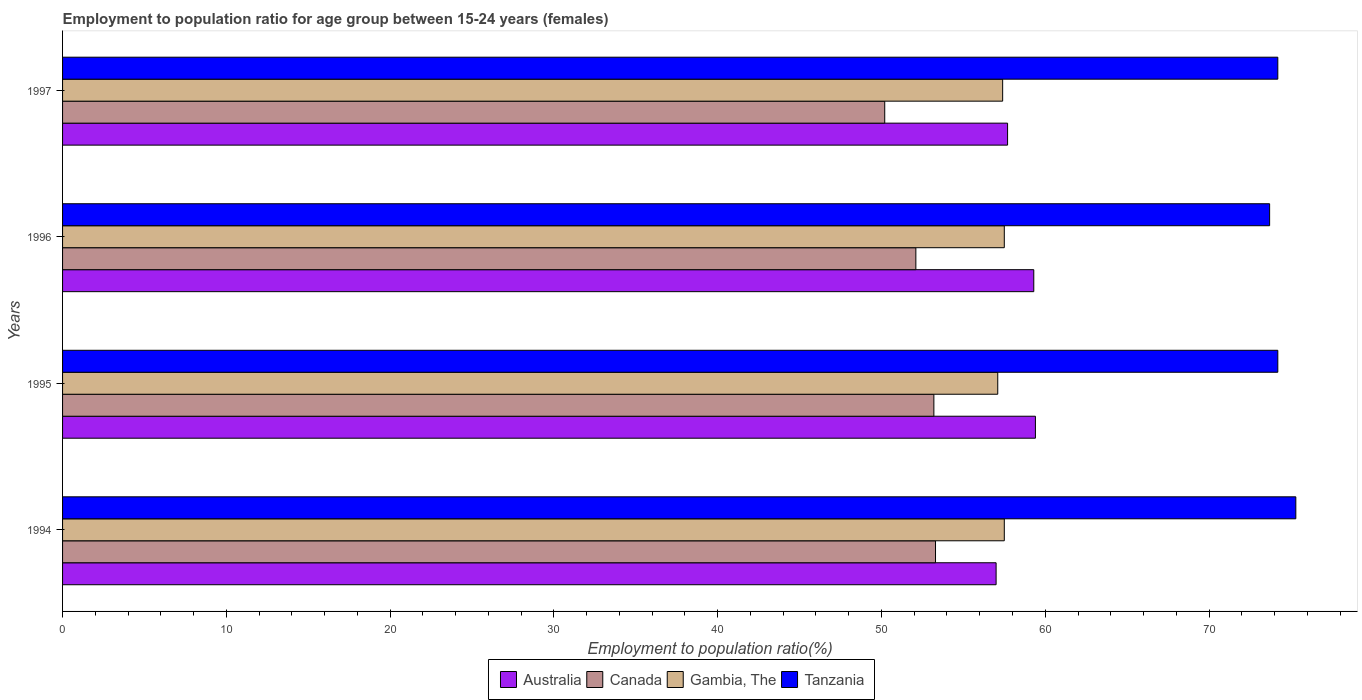How many different coloured bars are there?
Offer a very short reply. 4. How many groups of bars are there?
Offer a very short reply. 4. Are the number of bars per tick equal to the number of legend labels?
Make the answer very short. Yes. Are the number of bars on each tick of the Y-axis equal?
Give a very brief answer. Yes. How many bars are there on the 4th tick from the top?
Provide a succinct answer. 4. What is the label of the 4th group of bars from the top?
Your answer should be compact. 1994. In how many cases, is the number of bars for a given year not equal to the number of legend labels?
Give a very brief answer. 0. What is the employment to population ratio in Gambia, The in 1995?
Ensure brevity in your answer.  57.1. Across all years, what is the maximum employment to population ratio in Gambia, The?
Your answer should be very brief. 57.5. Across all years, what is the minimum employment to population ratio in Gambia, The?
Offer a terse response. 57.1. What is the total employment to population ratio in Tanzania in the graph?
Your answer should be compact. 297.4. What is the difference between the employment to population ratio in Australia in 1994 and that in 1997?
Give a very brief answer. -0.7. What is the difference between the employment to population ratio in Australia in 1996 and the employment to population ratio in Canada in 1997?
Your answer should be compact. 9.1. What is the average employment to population ratio in Tanzania per year?
Keep it short and to the point. 74.35. In the year 1994, what is the difference between the employment to population ratio in Tanzania and employment to population ratio in Canada?
Make the answer very short. 22. What is the ratio of the employment to population ratio in Gambia, The in 1995 to that in 1996?
Give a very brief answer. 0.99. Is the employment to population ratio in Gambia, The in 1995 less than that in 1996?
Keep it short and to the point. Yes. What is the difference between the highest and the second highest employment to population ratio in Australia?
Your response must be concise. 0.1. What is the difference between the highest and the lowest employment to population ratio in Australia?
Your response must be concise. 2.4. What does the 4th bar from the top in 1996 represents?
Provide a short and direct response. Australia. Is it the case that in every year, the sum of the employment to population ratio in Australia and employment to population ratio in Gambia, The is greater than the employment to population ratio in Tanzania?
Keep it short and to the point. Yes. How many years are there in the graph?
Your response must be concise. 4. Where does the legend appear in the graph?
Provide a succinct answer. Bottom center. What is the title of the graph?
Your response must be concise. Employment to population ratio for age group between 15-24 years (females). Does "Luxembourg" appear as one of the legend labels in the graph?
Your answer should be compact. No. What is the label or title of the X-axis?
Make the answer very short. Employment to population ratio(%). What is the Employment to population ratio(%) in Australia in 1994?
Your answer should be very brief. 57. What is the Employment to population ratio(%) in Canada in 1994?
Your response must be concise. 53.3. What is the Employment to population ratio(%) of Gambia, The in 1994?
Offer a very short reply. 57.5. What is the Employment to population ratio(%) in Tanzania in 1994?
Ensure brevity in your answer.  75.3. What is the Employment to population ratio(%) in Australia in 1995?
Give a very brief answer. 59.4. What is the Employment to population ratio(%) of Canada in 1995?
Provide a short and direct response. 53.2. What is the Employment to population ratio(%) of Gambia, The in 1995?
Your answer should be very brief. 57.1. What is the Employment to population ratio(%) in Tanzania in 1995?
Offer a very short reply. 74.2. What is the Employment to population ratio(%) in Australia in 1996?
Offer a very short reply. 59.3. What is the Employment to population ratio(%) in Canada in 1996?
Provide a short and direct response. 52.1. What is the Employment to population ratio(%) in Gambia, The in 1996?
Offer a terse response. 57.5. What is the Employment to population ratio(%) of Tanzania in 1996?
Make the answer very short. 73.7. What is the Employment to population ratio(%) in Australia in 1997?
Your response must be concise. 57.7. What is the Employment to population ratio(%) in Canada in 1997?
Ensure brevity in your answer.  50.2. What is the Employment to population ratio(%) in Gambia, The in 1997?
Provide a short and direct response. 57.4. What is the Employment to population ratio(%) in Tanzania in 1997?
Your answer should be compact. 74.2. Across all years, what is the maximum Employment to population ratio(%) in Australia?
Give a very brief answer. 59.4. Across all years, what is the maximum Employment to population ratio(%) in Canada?
Give a very brief answer. 53.3. Across all years, what is the maximum Employment to population ratio(%) in Gambia, The?
Give a very brief answer. 57.5. Across all years, what is the maximum Employment to population ratio(%) in Tanzania?
Your answer should be very brief. 75.3. Across all years, what is the minimum Employment to population ratio(%) of Australia?
Your response must be concise. 57. Across all years, what is the minimum Employment to population ratio(%) in Canada?
Give a very brief answer. 50.2. Across all years, what is the minimum Employment to population ratio(%) of Gambia, The?
Offer a terse response. 57.1. Across all years, what is the minimum Employment to population ratio(%) in Tanzania?
Provide a succinct answer. 73.7. What is the total Employment to population ratio(%) in Australia in the graph?
Keep it short and to the point. 233.4. What is the total Employment to population ratio(%) of Canada in the graph?
Provide a succinct answer. 208.8. What is the total Employment to population ratio(%) of Gambia, The in the graph?
Your response must be concise. 229.5. What is the total Employment to population ratio(%) of Tanzania in the graph?
Give a very brief answer. 297.4. What is the difference between the Employment to population ratio(%) of Australia in 1994 and that in 1995?
Your response must be concise. -2.4. What is the difference between the Employment to population ratio(%) in Canada in 1994 and that in 1995?
Your response must be concise. 0.1. What is the difference between the Employment to population ratio(%) in Gambia, The in 1994 and that in 1996?
Provide a short and direct response. 0. What is the difference between the Employment to population ratio(%) in Tanzania in 1994 and that in 1996?
Provide a succinct answer. 1.6. What is the difference between the Employment to population ratio(%) in Gambia, The in 1994 and that in 1997?
Keep it short and to the point. 0.1. What is the difference between the Employment to population ratio(%) of Gambia, The in 1995 and that in 1996?
Provide a succinct answer. -0.4. What is the difference between the Employment to population ratio(%) in Tanzania in 1995 and that in 1996?
Give a very brief answer. 0.5. What is the difference between the Employment to population ratio(%) in Canada in 1995 and that in 1997?
Ensure brevity in your answer.  3. What is the difference between the Employment to population ratio(%) in Gambia, The in 1995 and that in 1997?
Give a very brief answer. -0.3. What is the difference between the Employment to population ratio(%) of Tanzania in 1995 and that in 1997?
Your answer should be compact. 0. What is the difference between the Employment to population ratio(%) in Gambia, The in 1996 and that in 1997?
Provide a succinct answer. 0.1. What is the difference between the Employment to population ratio(%) in Tanzania in 1996 and that in 1997?
Keep it short and to the point. -0.5. What is the difference between the Employment to population ratio(%) of Australia in 1994 and the Employment to population ratio(%) of Canada in 1995?
Ensure brevity in your answer.  3.8. What is the difference between the Employment to population ratio(%) in Australia in 1994 and the Employment to population ratio(%) in Gambia, The in 1995?
Offer a very short reply. -0.1. What is the difference between the Employment to population ratio(%) of Australia in 1994 and the Employment to population ratio(%) of Tanzania in 1995?
Make the answer very short. -17.2. What is the difference between the Employment to population ratio(%) of Canada in 1994 and the Employment to population ratio(%) of Tanzania in 1995?
Offer a very short reply. -20.9. What is the difference between the Employment to population ratio(%) in Gambia, The in 1994 and the Employment to population ratio(%) in Tanzania in 1995?
Your answer should be compact. -16.7. What is the difference between the Employment to population ratio(%) of Australia in 1994 and the Employment to population ratio(%) of Gambia, The in 1996?
Give a very brief answer. -0.5. What is the difference between the Employment to population ratio(%) in Australia in 1994 and the Employment to population ratio(%) in Tanzania in 1996?
Ensure brevity in your answer.  -16.7. What is the difference between the Employment to population ratio(%) of Canada in 1994 and the Employment to population ratio(%) of Gambia, The in 1996?
Ensure brevity in your answer.  -4.2. What is the difference between the Employment to population ratio(%) in Canada in 1994 and the Employment to population ratio(%) in Tanzania in 1996?
Your answer should be compact. -20.4. What is the difference between the Employment to population ratio(%) in Gambia, The in 1994 and the Employment to population ratio(%) in Tanzania in 1996?
Keep it short and to the point. -16.2. What is the difference between the Employment to population ratio(%) of Australia in 1994 and the Employment to population ratio(%) of Tanzania in 1997?
Offer a very short reply. -17.2. What is the difference between the Employment to population ratio(%) of Canada in 1994 and the Employment to population ratio(%) of Gambia, The in 1997?
Keep it short and to the point. -4.1. What is the difference between the Employment to population ratio(%) in Canada in 1994 and the Employment to population ratio(%) in Tanzania in 1997?
Provide a succinct answer. -20.9. What is the difference between the Employment to population ratio(%) of Gambia, The in 1994 and the Employment to population ratio(%) of Tanzania in 1997?
Provide a short and direct response. -16.7. What is the difference between the Employment to population ratio(%) in Australia in 1995 and the Employment to population ratio(%) in Tanzania in 1996?
Provide a succinct answer. -14.3. What is the difference between the Employment to population ratio(%) of Canada in 1995 and the Employment to population ratio(%) of Gambia, The in 1996?
Offer a very short reply. -4.3. What is the difference between the Employment to population ratio(%) in Canada in 1995 and the Employment to population ratio(%) in Tanzania in 1996?
Offer a very short reply. -20.5. What is the difference between the Employment to population ratio(%) of Gambia, The in 1995 and the Employment to population ratio(%) of Tanzania in 1996?
Give a very brief answer. -16.6. What is the difference between the Employment to population ratio(%) in Australia in 1995 and the Employment to population ratio(%) in Canada in 1997?
Your response must be concise. 9.2. What is the difference between the Employment to population ratio(%) of Australia in 1995 and the Employment to population ratio(%) of Tanzania in 1997?
Your answer should be compact. -14.8. What is the difference between the Employment to population ratio(%) in Gambia, The in 1995 and the Employment to population ratio(%) in Tanzania in 1997?
Ensure brevity in your answer.  -17.1. What is the difference between the Employment to population ratio(%) of Australia in 1996 and the Employment to population ratio(%) of Canada in 1997?
Offer a terse response. 9.1. What is the difference between the Employment to population ratio(%) in Australia in 1996 and the Employment to population ratio(%) in Tanzania in 1997?
Offer a terse response. -14.9. What is the difference between the Employment to population ratio(%) of Canada in 1996 and the Employment to population ratio(%) of Tanzania in 1997?
Provide a succinct answer. -22.1. What is the difference between the Employment to population ratio(%) of Gambia, The in 1996 and the Employment to population ratio(%) of Tanzania in 1997?
Your response must be concise. -16.7. What is the average Employment to population ratio(%) of Australia per year?
Keep it short and to the point. 58.35. What is the average Employment to population ratio(%) of Canada per year?
Ensure brevity in your answer.  52.2. What is the average Employment to population ratio(%) in Gambia, The per year?
Your response must be concise. 57.38. What is the average Employment to population ratio(%) of Tanzania per year?
Offer a terse response. 74.35. In the year 1994, what is the difference between the Employment to population ratio(%) in Australia and Employment to population ratio(%) in Gambia, The?
Provide a short and direct response. -0.5. In the year 1994, what is the difference between the Employment to population ratio(%) in Australia and Employment to population ratio(%) in Tanzania?
Keep it short and to the point. -18.3. In the year 1994, what is the difference between the Employment to population ratio(%) in Canada and Employment to population ratio(%) in Tanzania?
Offer a terse response. -22. In the year 1994, what is the difference between the Employment to population ratio(%) in Gambia, The and Employment to population ratio(%) in Tanzania?
Offer a very short reply. -17.8. In the year 1995, what is the difference between the Employment to population ratio(%) in Australia and Employment to population ratio(%) in Canada?
Offer a very short reply. 6.2. In the year 1995, what is the difference between the Employment to population ratio(%) of Australia and Employment to population ratio(%) of Gambia, The?
Give a very brief answer. 2.3. In the year 1995, what is the difference between the Employment to population ratio(%) in Australia and Employment to population ratio(%) in Tanzania?
Your answer should be compact. -14.8. In the year 1995, what is the difference between the Employment to population ratio(%) in Gambia, The and Employment to population ratio(%) in Tanzania?
Your answer should be very brief. -17.1. In the year 1996, what is the difference between the Employment to population ratio(%) in Australia and Employment to population ratio(%) in Canada?
Keep it short and to the point. 7.2. In the year 1996, what is the difference between the Employment to population ratio(%) of Australia and Employment to population ratio(%) of Tanzania?
Your response must be concise. -14.4. In the year 1996, what is the difference between the Employment to population ratio(%) in Canada and Employment to population ratio(%) in Tanzania?
Give a very brief answer. -21.6. In the year 1996, what is the difference between the Employment to population ratio(%) in Gambia, The and Employment to population ratio(%) in Tanzania?
Keep it short and to the point. -16.2. In the year 1997, what is the difference between the Employment to population ratio(%) in Australia and Employment to population ratio(%) in Canada?
Offer a terse response. 7.5. In the year 1997, what is the difference between the Employment to population ratio(%) in Australia and Employment to population ratio(%) in Gambia, The?
Keep it short and to the point. 0.3. In the year 1997, what is the difference between the Employment to population ratio(%) of Australia and Employment to population ratio(%) of Tanzania?
Offer a very short reply. -16.5. In the year 1997, what is the difference between the Employment to population ratio(%) in Canada and Employment to population ratio(%) in Gambia, The?
Provide a succinct answer. -7.2. In the year 1997, what is the difference between the Employment to population ratio(%) in Canada and Employment to population ratio(%) in Tanzania?
Your answer should be very brief. -24. In the year 1997, what is the difference between the Employment to population ratio(%) in Gambia, The and Employment to population ratio(%) in Tanzania?
Your answer should be compact. -16.8. What is the ratio of the Employment to population ratio(%) in Australia in 1994 to that in 1995?
Make the answer very short. 0.96. What is the ratio of the Employment to population ratio(%) in Canada in 1994 to that in 1995?
Ensure brevity in your answer.  1. What is the ratio of the Employment to population ratio(%) in Gambia, The in 1994 to that in 1995?
Your response must be concise. 1.01. What is the ratio of the Employment to population ratio(%) of Tanzania in 1994 to that in 1995?
Provide a short and direct response. 1.01. What is the ratio of the Employment to population ratio(%) in Australia in 1994 to that in 1996?
Ensure brevity in your answer.  0.96. What is the ratio of the Employment to population ratio(%) in Canada in 1994 to that in 1996?
Offer a very short reply. 1.02. What is the ratio of the Employment to population ratio(%) in Tanzania in 1994 to that in 1996?
Keep it short and to the point. 1.02. What is the ratio of the Employment to population ratio(%) of Australia in 1994 to that in 1997?
Give a very brief answer. 0.99. What is the ratio of the Employment to population ratio(%) of Canada in 1994 to that in 1997?
Your answer should be compact. 1.06. What is the ratio of the Employment to population ratio(%) of Gambia, The in 1994 to that in 1997?
Offer a terse response. 1. What is the ratio of the Employment to population ratio(%) in Tanzania in 1994 to that in 1997?
Offer a very short reply. 1.01. What is the ratio of the Employment to population ratio(%) in Canada in 1995 to that in 1996?
Give a very brief answer. 1.02. What is the ratio of the Employment to population ratio(%) of Gambia, The in 1995 to that in 1996?
Provide a short and direct response. 0.99. What is the ratio of the Employment to population ratio(%) in Tanzania in 1995 to that in 1996?
Provide a short and direct response. 1.01. What is the ratio of the Employment to population ratio(%) in Australia in 1995 to that in 1997?
Offer a terse response. 1.03. What is the ratio of the Employment to population ratio(%) in Canada in 1995 to that in 1997?
Offer a terse response. 1.06. What is the ratio of the Employment to population ratio(%) of Gambia, The in 1995 to that in 1997?
Keep it short and to the point. 0.99. What is the ratio of the Employment to population ratio(%) in Australia in 1996 to that in 1997?
Your answer should be very brief. 1.03. What is the ratio of the Employment to population ratio(%) of Canada in 1996 to that in 1997?
Give a very brief answer. 1.04. What is the ratio of the Employment to population ratio(%) of Gambia, The in 1996 to that in 1997?
Give a very brief answer. 1. What is the ratio of the Employment to population ratio(%) in Tanzania in 1996 to that in 1997?
Make the answer very short. 0.99. What is the difference between the highest and the second highest Employment to population ratio(%) of Australia?
Keep it short and to the point. 0.1. What is the difference between the highest and the second highest Employment to population ratio(%) of Canada?
Keep it short and to the point. 0.1. What is the difference between the highest and the second highest Employment to population ratio(%) in Tanzania?
Provide a short and direct response. 1.1. What is the difference between the highest and the lowest Employment to population ratio(%) of Australia?
Ensure brevity in your answer.  2.4. What is the difference between the highest and the lowest Employment to population ratio(%) in Canada?
Your answer should be compact. 3.1. 